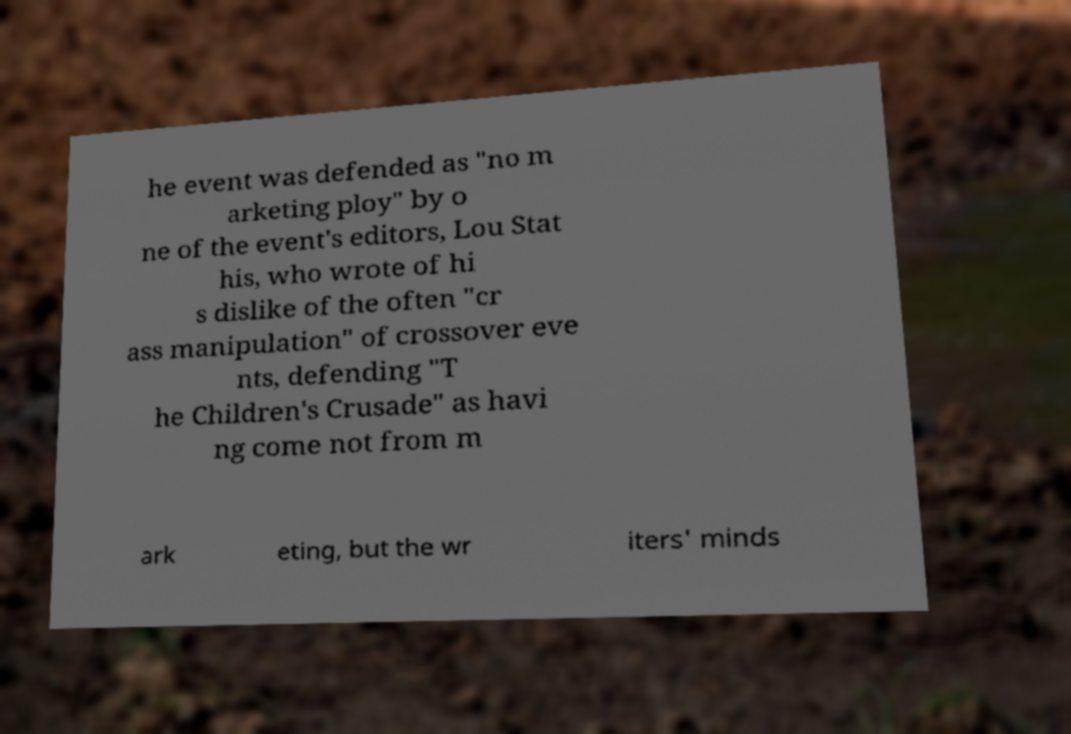Could you extract and type out the text from this image? he event was defended as "no m arketing ploy" by o ne of the event's editors, Lou Stat his, who wrote of hi s dislike of the often "cr ass manipulation" of crossover eve nts, defending "T he Children's Crusade" as havi ng come not from m ark eting, but the wr iters' minds 